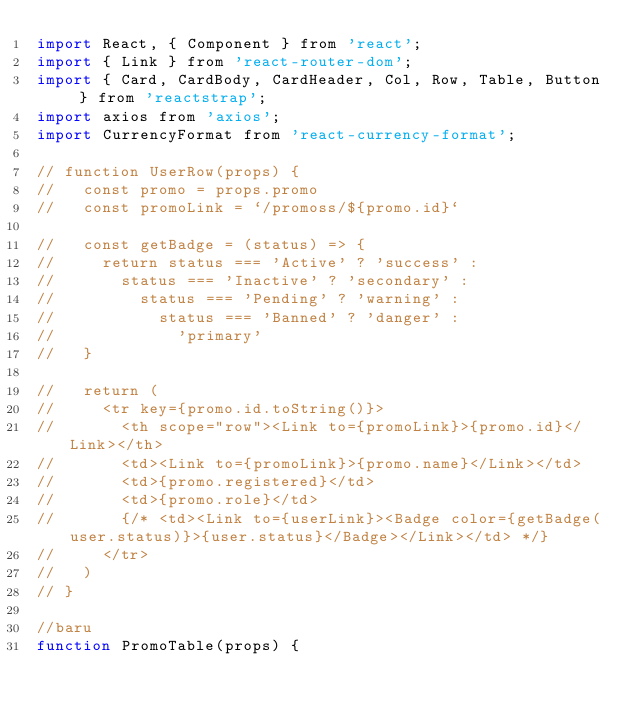Convert code to text. <code><loc_0><loc_0><loc_500><loc_500><_JavaScript_>import React, { Component } from 'react';
import { Link } from 'react-router-dom';
import { Card, CardBody, CardHeader, Col, Row, Table, Button } from 'reactstrap';
import axios from 'axios';
import CurrencyFormat from 'react-currency-format';

// function UserRow(props) {
//   const promo = props.promo
//   const promoLink = `/promoss/${promo.id}`

//   const getBadge = (status) => {
//     return status === 'Active' ? 'success' :
//       status === 'Inactive' ? 'secondary' :
//         status === 'Pending' ? 'warning' :
//           status === 'Banned' ? 'danger' :
//             'primary'
//   }

//   return (
//     <tr key={promo.id.toString()}>
//       <th scope="row"><Link to={promoLink}>{promo.id}</Link></th>
//       <td><Link to={promoLink}>{promo.name}</Link></td>
//       <td>{promo.registered}</td>
//       <td>{promo.role}</td>
//       {/* <td><Link to={userLink}><Badge color={getBadge(user.status)}>{user.status}</Badge></Link></td> */}
//     </tr>
//   )
// }

//baru
function PromoTable(props) {</code> 